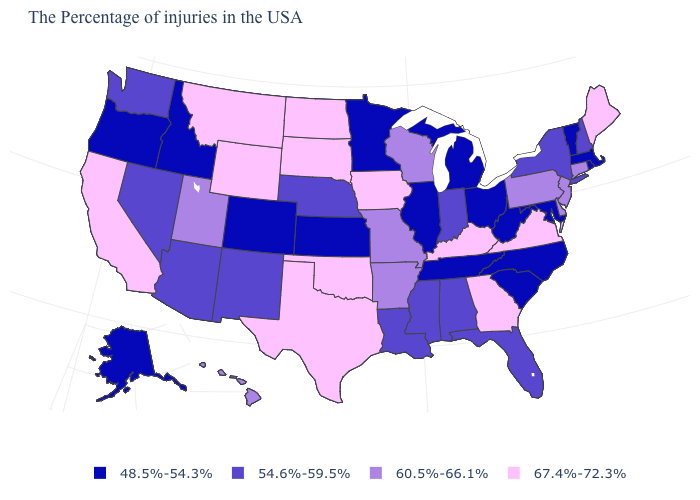Name the states that have a value in the range 54.6%-59.5%?
Short answer required. New Hampshire, New York, Florida, Indiana, Alabama, Mississippi, Louisiana, Nebraska, New Mexico, Arizona, Nevada, Washington. Is the legend a continuous bar?
Write a very short answer. No. What is the value of South Dakota?
Be succinct. 67.4%-72.3%. Among the states that border Virginia , which have the highest value?
Give a very brief answer. Kentucky. Does Wyoming have the highest value in the USA?
Concise answer only. Yes. Name the states that have a value in the range 48.5%-54.3%?
Write a very short answer. Massachusetts, Rhode Island, Vermont, Maryland, North Carolina, South Carolina, West Virginia, Ohio, Michigan, Tennessee, Illinois, Minnesota, Kansas, Colorado, Idaho, Oregon, Alaska. What is the value of Delaware?
Be succinct. 60.5%-66.1%. Name the states that have a value in the range 60.5%-66.1%?
Concise answer only. Connecticut, New Jersey, Delaware, Pennsylvania, Wisconsin, Missouri, Arkansas, Utah, Hawaii. What is the lowest value in states that border Connecticut?
Give a very brief answer. 48.5%-54.3%. What is the lowest value in states that border Alabama?
Keep it brief. 48.5%-54.3%. Name the states that have a value in the range 67.4%-72.3%?
Answer briefly. Maine, Virginia, Georgia, Kentucky, Iowa, Oklahoma, Texas, South Dakota, North Dakota, Wyoming, Montana, California. Does Idaho have the lowest value in the USA?
Quick response, please. Yes. Which states have the highest value in the USA?
Short answer required. Maine, Virginia, Georgia, Kentucky, Iowa, Oklahoma, Texas, South Dakota, North Dakota, Wyoming, Montana, California. Name the states that have a value in the range 54.6%-59.5%?
Answer briefly. New Hampshire, New York, Florida, Indiana, Alabama, Mississippi, Louisiana, Nebraska, New Mexico, Arizona, Nevada, Washington. Among the states that border Utah , which have the highest value?
Concise answer only. Wyoming. 